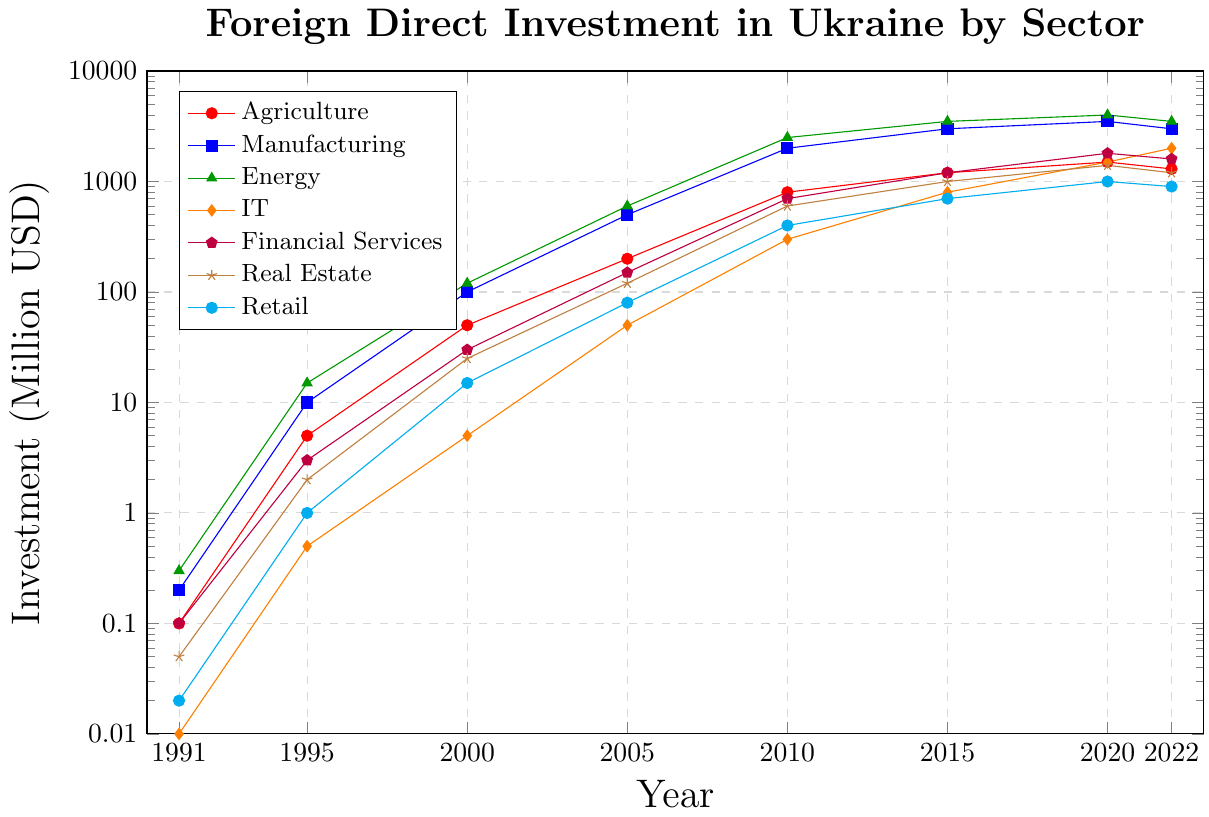What was the trend of foreign direct investment (FDI) in the Energy sector from 1991 to 2022? The Energy sector shows a general increase in FDI over the period. There was a small investment of $0.3 million in 1991, which grew substantially to $15 million by 1995 and continued to surge to $600 million by 2005. It reached $4000 million by 2020 but slightly decreased to $3500 million in 2022.
Answer: Increasing trend, with a slight decrease from 2020 to 2022 How did the FDI in Agriculture compare to the FDI in Manufacturing in 2010? In 2010, Agriculture had an FDI of $800 million, while Manufacturing had an FDI of $2000 million. Therefore, Manufacturing had significantly higher FDI compared to Agriculture.
Answer: Manufacturing had higher FDI Which sector had the largest FDI in 2015, and how much was it? By inspecting the graph for the year 2015, the Energy sector had the largest FDI, amounting to $3500 million.
Answer: Energy with $3500 million What was the total FDI in IT and Agriculture sectors in 2005? In 2005, the FDI in IT was $50 million and in Agriculture was $200 million. The total FDI is calculated by summing these values: $50 million (IT) + $200 million (Agriculture) = $250 million.
Answer: $250 million By how much did FDI in the Financial Services sector increase from 2000 to 2020? In 2000, the FDI in Financial Services was $30 million, and in 2020, it was $1800 million. The increase is calculated by subtracting the initial amount from the final amount: $1800 million - $30 million = $1770 million.
Answer: $1770 million Which year saw the highest FDI in the Real Estate sector, and what was the investment amount? The graph indicates that the highest FDI in the Real Estate sector was in 2020, with an investment amount of $1400 million.
Answer: 2020 with $1400 million Did the FDI in Retail ever exceed $1000 million? If so, in which year(s)? Reviewing the graph, the FDI in Retail reached $1000 million in 2020, thus exceeding $1000 million only in that specific year.
Answer: Yes, in 2020 How does the FDI in Agriculture in 1995 compare to that in Retail in the same year? In 1995, the FDI in Agriculture was $5 million, while in Retail it was $1 million. Hence, Agriculture had a higher FDI compared to Retail in that year.
Answer: Agriculture had higher FDI What is the average FDI in the IT sector over the years presented? To find the average, sum all the FDI values in the IT sector and then divide by the number of years: ($0.01 + $0.5 + $5 + $50 + $300 + $800 + $1500 + $2000) million = $4655.51 million. The number of years is 8. So, the average is $4655.51 million / 8 ≈ $581.94 million.
Answer: Approximately $581.94 million 